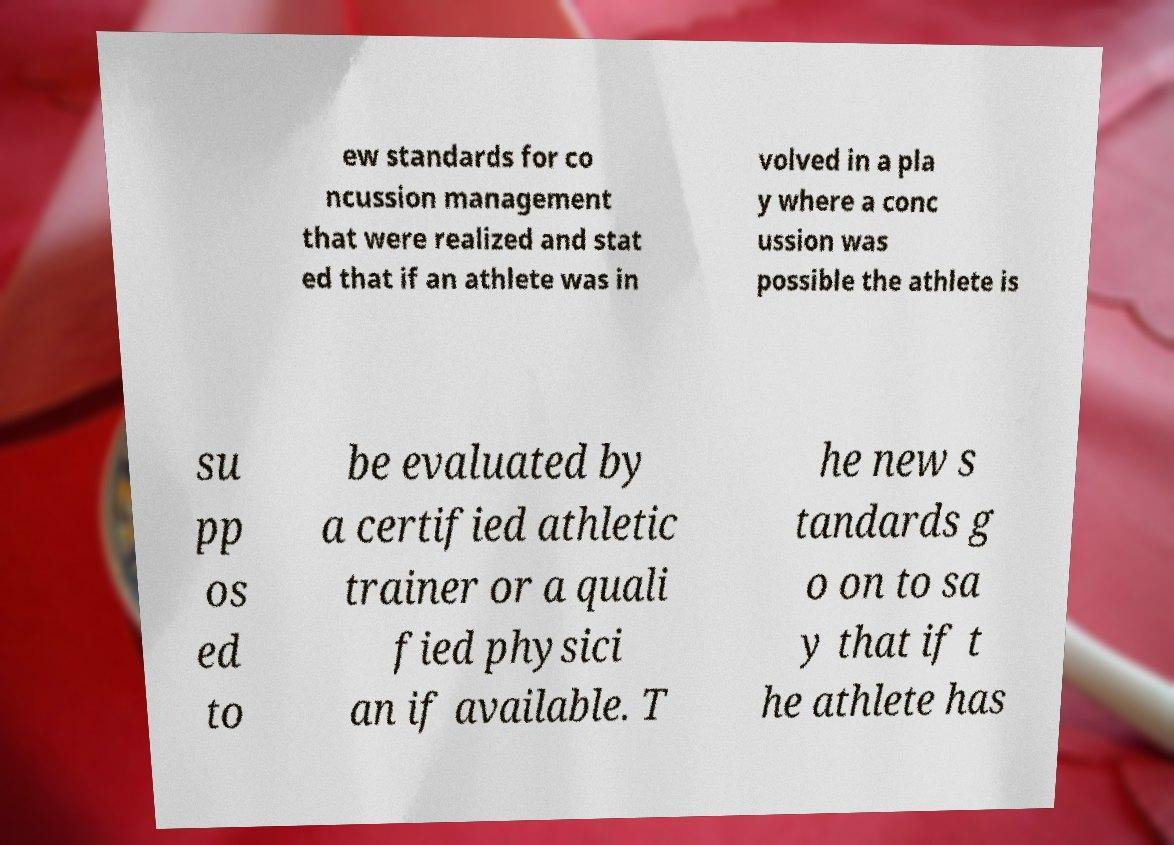Could you extract and type out the text from this image? ew standards for co ncussion management that were realized and stat ed that if an athlete was in volved in a pla y where a conc ussion was possible the athlete is su pp os ed to be evaluated by a certified athletic trainer or a quali fied physici an if available. T he new s tandards g o on to sa y that if t he athlete has 